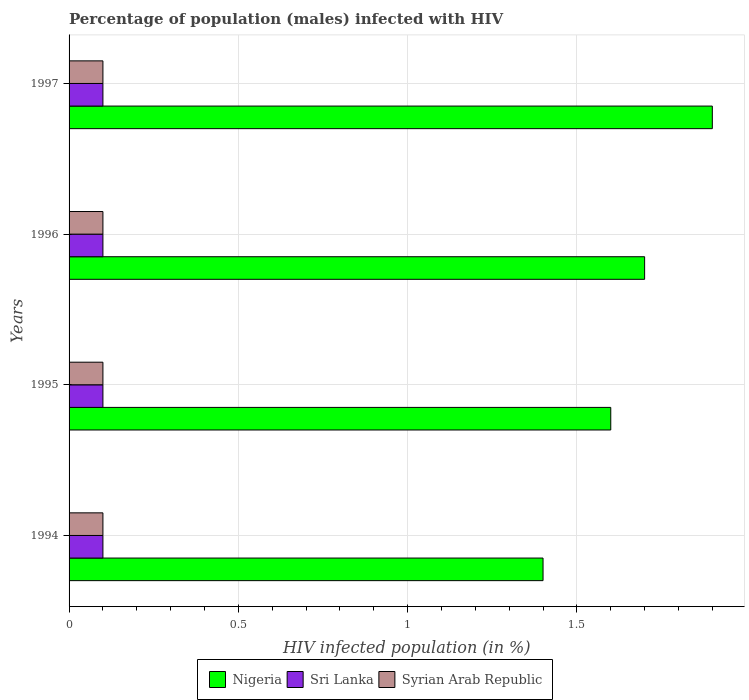Are the number of bars per tick equal to the number of legend labels?
Give a very brief answer. Yes. In how many cases, is the number of bars for a given year not equal to the number of legend labels?
Your answer should be compact. 0. What is the percentage of HIV infected male population in Syrian Arab Republic in 1996?
Make the answer very short. 0.1. In which year was the percentage of HIV infected male population in Sri Lanka maximum?
Offer a terse response. 1994. What is the difference between the percentage of HIV infected male population in Nigeria in 1994 and that in 1995?
Your response must be concise. -0.2. What is the average percentage of HIV infected male population in Sri Lanka per year?
Offer a very short reply. 0.1. In the year 1994, what is the difference between the percentage of HIV infected male population in Syrian Arab Republic and percentage of HIV infected male population in Nigeria?
Ensure brevity in your answer.  -1.3. What is the ratio of the percentage of HIV infected male population in Nigeria in 1996 to that in 1997?
Keep it short and to the point. 0.89. Is the percentage of HIV infected male population in Nigeria in 1994 less than that in 1997?
Give a very brief answer. Yes. Is the difference between the percentage of HIV infected male population in Syrian Arab Republic in 1996 and 1997 greater than the difference between the percentage of HIV infected male population in Nigeria in 1996 and 1997?
Your answer should be compact. Yes. What is the difference between the highest and the second highest percentage of HIV infected male population in Nigeria?
Your answer should be compact. 0.2. What is the difference between the highest and the lowest percentage of HIV infected male population in Syrian Arab Republic?
Offer a very short reply. 0. In how many years, is the percentage of HIV infected male population in Syrian Arab Republic greater than the average percentage of HIV infected male population in Syrian Arab Republic taken over all years?
Ensure brevity in your answer.  0. What does the 3rd bar from the top in 1994 represents?
Ensure brevity in your answer.  Nigeria. What does the 3rd bar from the bottom in 1996 represents?
Make the answer very short. Syrian Arab Republic. How many bars are there?
Offer a very short reply. 12. Are all the bars in the graph horizontal?
Make the answer very short. Yes. Are the values on the major ticks of X-axis written in scientific E-notation?
Make the answer very short. No. Does the graph contain grids?
Your answer should be compact. Yes. How are the legend labels stacked?
Your answer should be very brief. Horizontal. What is the title of the graph?
Your answer should be very brief. Percentage of population (males) infected with HIV. Does "India" appear as one of the legend labels in the graph?
Make the answer very short. No. What is the label or title of the X-axis?
Ensure brevity in your answer.  HIV infected population (in %). What is the HIV infected population (in %) in Nigeria in 1994?
Provide a succinct answer. 1.4. What is the HIV infected population (in %) in Syrian Arab Republic in 1994?
Make the answer very short. 0.1. What is the HIV infected population (in %) in Nigeria in 1995?
Your answer should be very brief. 1.6. Across all years, what is the maximum HIV infected population (in %) of Nigeria?
Provide a short and direct response. 1.9. Across all years, what is the minimum HIV infected population (in %) in Sri Lanka?
Ensure brevity in your answer.  0.1. Across all years, what is the minimum HIV infected population (in %) of Syrian Arab Republic?
Give a very brief answer. 0.1. What is the total HIV infected population (in %) of Nigeria in the graph?
Your response must be concise. 6.6. What is the total HIV infected population (in %) in Syrian Arab Republic in the graph?
Your response must be concise. 0.4. What is the difference between the HIV infected population (in %) in Nigeria in 1994 and that in 1995?
Ensure brevity in your answer.  -0.2. What is the difference between the HIV infected population (in %) of Sri Lanka in 1994 and that in 1996?
Make the answer very short. 0. What is the difference between the HIV infected population (in %) in Nigeria in 1994 and that in 1997?
Offer a very short reply. -0.5. What is the difference between the HIV infected population (in %) of Syrian Arab Republic in 1994 and that in 1997?
Offer a very short reply. 0. What is the difference between the HIV infected population (in %) in Nigeria in 1995 and that in 1996?
Your answer should be compact. -0.1. What is the difference between the HIV infected population (in %) in Syrian Arab Republic in 1995 and that in 1996?
Provide a succinct answer. 0. What is the difference between the HIV infected population (in %) of Nigeria in 1996 and that in 1997?
Give a very brief answer. -0.2. What is the difference between the HIV infected population (in %) of Sri Lanka in 1996 and that in 1997?
Offer a very short reply. 0. What is the difference between the HIV infected population (in %) of Nigeria in 1994 and the HIV infected population (in %) of Sri Lanka in 1995?
Give a very brief answer. 1.3. What is the difference between the HIV infected population (in %) of Nigeria in 1994 and the HIV infected population (in %) of Sri Lanka in 1996?
Make the answer very short. 1.3. What is the difference between the HIV infected population (in %) in Nigeria in 1994 and the HIV infected population (in %) in Syrian Arab Republic in 1996?
Offer a very short reply. 1.3. What is the difference between the HIV infected population (in %) in Sri Lanka in 1994 and the HIV infected population (in %) in Syrian Arab Republic in 1996?
Offer a very short reply. 0. What is the difference between the HIV infected population (in %) in Nigeria in 1995 and the HIV infected population (in %) in Sri Lanka in 1996?
Ensure brevity in your answer.  1.5. What is the difference between the HIV infected population (in %) in Nigeria in 1995 and the HIV infected population (in %) in Syrian Arab Republic in 1996?
Make the answer very short. 1.5. What is the difference between the HIV infected population (in %) of Sri Lanka in 1995 and the HIV infected population (in %) of Syrian Arab Republic in 1996?
Keep it short and to the point. 0. What is the difference between the HIV infected population (in %) in Nigeria in 1995 and the HIV infected population (in %) in Sri Lanka in 1997?
Make the answer very short. 1.5. What is the difference between the HIV infected population (in %) of Nigeria in 1995 and the HIV infected population (in %) of Syrian Arab Republic in 1997?
Your response must be concise. 1.5. What is the difference between the HIV infected population (in %) of Sri Lanka in 1995 and the HIV infected population (in %) of Syrian Arab Republic in 1997?
Your answer should be compact. 0. What is the difference between the HIV infected population (in %) in Nigeria in 1996 and the HIV infected population (in %) in Sri Lanka in 1997?
Ensure brevity in your answer.  1.6. What is the difference between the HIV infected population (in %) of Nigeria in 1996 and the HIV infected population (in %) of Syrian Arab Republic in 1997?
Your answer should be compact. 1.6. What is the average HIV infected population (in %) in Nigeria per year?
Provide a short and direct response. 1.65. What is the average HIV infected population (in %) in Sri Lanka per year?
Provide a short and direct response. 0.1. What is the average HIV infected population (in %) in Syrian Arab Republic per year?
Ensure brevity in your answer.  0.1. In the year 1994, what is the difference between the HIV infected population (in %) in Sri Lanka and HIV infected population (in %) in Syrian Arab Republic?
Your response must be concise. 0. In the year 1995, what is the difference between the HIV infected population (in %) in Nigeria and HIV infected population (in %) in Sri Lanka?
Offer a terse response. 1.5. In the year 1995, what is the difference between the HIV infected population (in %) in Sri Lanka and HIV infected population (in %) in Syrian Arab Republic?
Offer a very short reply. 0. In the year 1996, what is the difference between the HIV infected population (in %) of Nigeria and HIV infected population (in %) of Sri Lanka?
Your answer should be very brief. 1.6. In the year 1997, what is the difference between the HIV infected population (in %) of Nigeria and HIV infected population (in %) of Sri Lanka?
Make the answer very short. 1.8. In the year 1997, what is the difference between the HIV infected population (in %) in Nigeria and HIV infected population (in %) in Syrian Arab Republic?
Offer a terse response. 1.8. In the year 1997, what is the difference between the HIV infected population (in %) of Sri Lanka and HIV infected population (in %) of Syrian Arab Republic?
Offer a terse response. 0. What is the ratio of the HIV infected population (in %) of Nigeria in 1994 to that in 1995?
Keep it short and to the point. 0.88. What is the ratio of the HIV infected population (in %) of Sri Lanka in 1994 to that in 1995?
Give a very brief answer. 1. What is the ratio of the HIV infected population (in %) in Syrian Arab Republic in 1994 to that in 1995?
Provide a succinct answer. 1. What is the ratio of the HIV infected population (in %) of Nigeria in 1994 to that in 1996?
Make the answer very short. 0.82. What is the ratio of the HIV infected population (in %) of Sri Lanka in 1994 to that in 1996?
Make the answer very short. 1. What is the ratio of the HIV infected population (in %) in Nigeria in 1994 to that in 1997?
Your answer should be very brief. 0.74. What is the ratio of the HIV infected population (in %) in Syrian Arab Republic in 1994 to that in 1997?
Keep it short and to the point. 1. What is the ratio of the HIV infected population (in %) of Nigeria in 1995 to that in 1996?
Your answer should be very brief. 0.94. What is the ratio of the HIV infected population (in %) in Sri Lanka in 1995 to that in 1996?
Your response must be concise. 1. What is the ratio of the HIV infected population (in %) of Syrian Arab Republic in 1995 to that in 1996?
Provide a succinct answer. 1. What is the ratio of the HIV infected population (in %) of Nigeria in 1995 to that in 1997?
Your answer should be very brief. 0.84. What is the ratio of the HIV infected population (in %) of Syrian Arab Republic in 1995 to that in 1997?
Offer a very short reply. 1. What is the ratio of the HIV infected population (in %) in Nigeria in 1996 to that in 1997?
Your answer should be compact. 0.89. What is the difference between the highest and the second highest HIV infected population (in %) in Nigeria?
Provide a succinct answer. 0.2. What is the difference between the highest and the second highest HIV infected population (in %) of Syrian Arab Republic?
Your answer should be very brief. 0. What is the difference between the highest and the lowest HIV infected population (in %) in Nigeria?
Offer a terse response. 0.5. What is the difference between the highest and the lowest HIV infected population (in %) in Syrian Arab Republic?
Offer a very short reply. 0. 